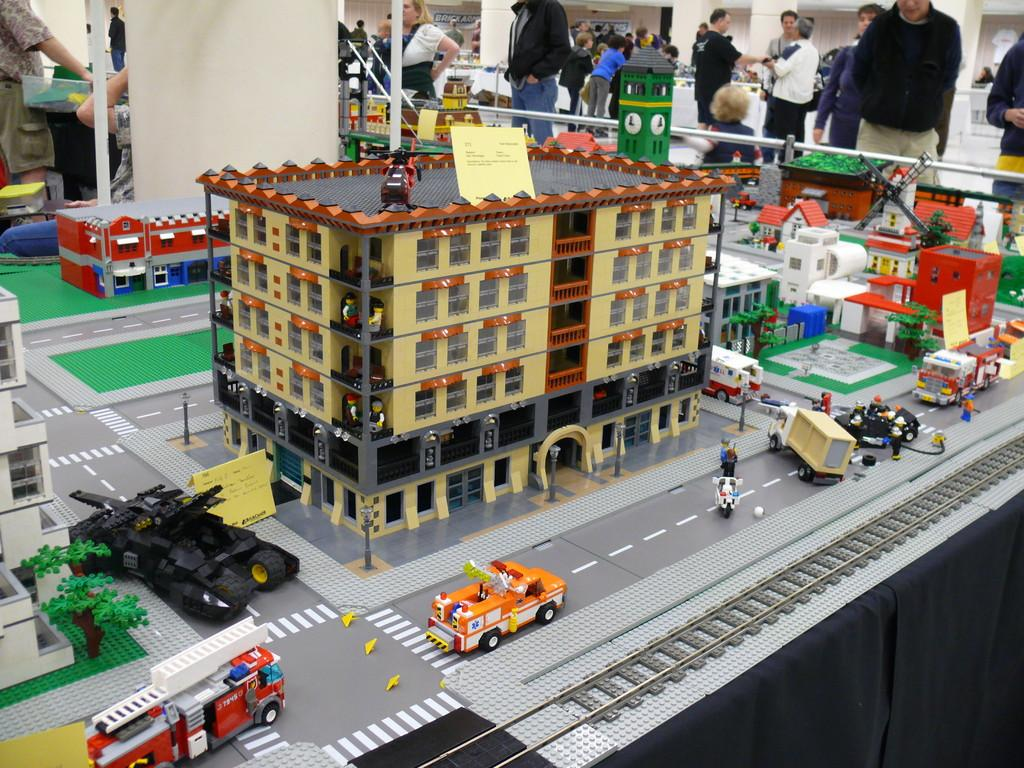What is the main subject of the image? The main subject of the image is a model of a building. What else can be seen in the image besides the building? There are vehicles in the image. Can you describe the people in the background of the image? People are standing in the background of the image. What type of vessel is being used by the people in the image? There is no vessel present in the image; it features a model of a building, vehicles, and people standing in the background. 